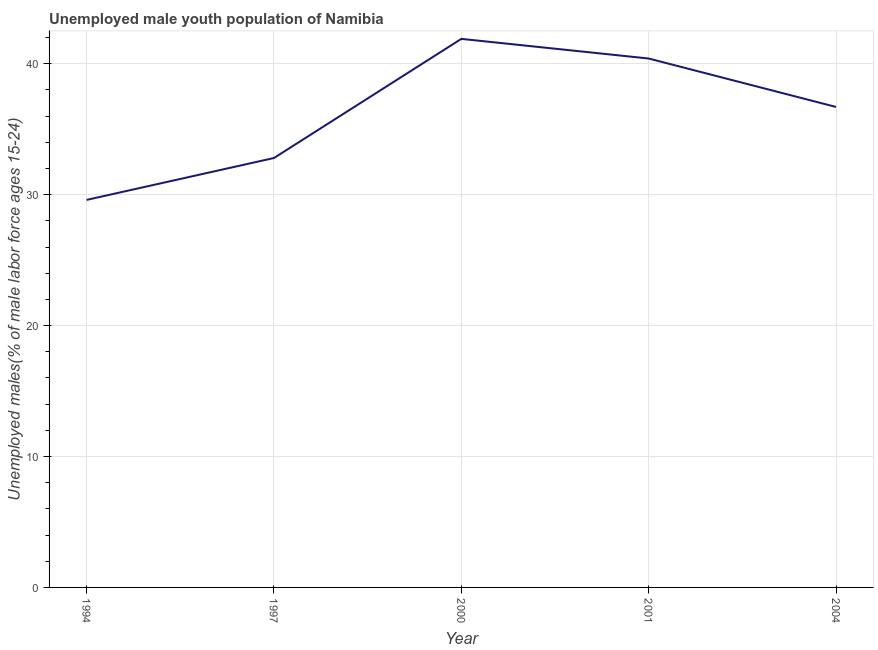What is the unemployed male youth in 2001?
Your answer should be compact. 40.4. Across all years, what is the maximum unemployed male youth?
Offer a terse response. 41.9. Across all years, what is the minimum unemployed male youth?
Your answer should be compact. 29.6. In which year was the unemployed male youth maximum?
Your answer should be compact. 2000. In which year was the unemployed male youth minimum?
Your answer should be compact. 1994. What is the sum of the unemployed male youth?
Make the answer very short. 181.4. What is the average unemployed male youth per year?
Offer a very short reply. 36.28. What is the median unemployed male youth?
Ensure brevity in your answer.  36.7. In how many years, is the unemployed male youth greater than 22 %?
Give a very brief answer. 5. Do a majority of the years between 2004 and 1997 (inclusive) have unemployed male youth greater than 24 %?
Provide a short and direct response. Yes. What is the ratio of the unemployed male youth in 2001 to that in 2004?
Provide a short and direct response. 1.1. Is the unemployed male youth in 1997 less than that in 2000?
Keep it short and to the point. Yes. What is the difference between the highest and the second highest unemployed male youth?
Offer a terse response. 1.5. Is the sum of the unemployed male youth in 2001 and 2004 greater than the maximum unemployed male youth across all years?
Offer a terse response. Yes. What is the difference between the highest and the lowest unemployed male youth?
Ensure brevity in your answer.  12.3. Does the unemployed male youth monotonically increase over the years?
Your answer should be very brief. No. What is the difference between two consecutive major ticks on the Y-axis?
Your response must be concise. 10. What is the title of the graph?
Provide a short and direct response. Unemployed male youth population of Namibia. What is the label or title of the Y-axis?
Your answer should be compact. Unemployed males(% of male labor force ages 15-24). What is the Unemployed males(% of male labor force ages 15-24) of 1994?
Provide a succinct answer. 29.6. What is the Unemployed males(% of male labor force ages 15-24) of 1997?
Make the answer very short. 32.8. What is the Unemployed males(% of male labor force ages 15-24) in 2000?
Give a very brief answer. 41.9. What is the Unemployed males(% of male labor force ages 15-24) in 2001?
Give a very brief answer. 40.4. What is the Unemployed males(% of male labor force ages 15-24) of 2004?
Keep it short and to the point. 36.7. What is the difference between the Unemployed males(% of male labor force ages 15-24) in 1994 and 1997?
Ensure brevity in your answer.  -3.2. What is the difference between the Unemployed males(% of male labor force ages 15-24) in 1994 and 2001?
Give a very brief answer. -10.8. What is the difference between the Unemployed males(% of male labor force ages 15-24) in 2001 and 2004?
Offer a very short reply. 3.7. What is the ratio of the Unemployed males(% of male labor force ages 15-24) in 1994 to that in 1997?
Make the answer very short. 0.9. What is the ratio of the Unemployed males(% of male labor force ages 15-24) in 1994 to that in 2000?
Make the answer very short. 0.71. What is the ratio of the Unemployed males(% of male labor force ages 15-24) in 1994 to that in 2001?
Offer a very short reply. 0.73. What is the ratio of the Unemployed males(% of male labor force ages 15-24) in 1994 to that in 2004?
Make the answer very short. 0.81. What is the ratio of the Unemployed males(% of male labor force ages 15-24) in 1997 to that in 2000?
Offer a very short reply. 0.78. What is the ratio of the Unemployed males(% of male labor force ages 15-24) in 1997 to that in 2001?
Provide a succinct answer. 0.81. What is the ratio of the Unemployed males(% of male labor force ages 15-24) in 1997 to that in 2004?
Keep it short and to the point. 0.89. What is the ratio of the Unemployed males(% of male labor force ages 15-24) in 2000 to that in 2001?
Provide a succinct answer. 1.04. What is the ratio of the Unemployed males(% of male labor force ages 15-24) in 2000 to that in 2004?
Your answer should be very brief. 1.14. What is the ratio of the Unemployed males(% of male labor force ages 15-24) in 2001 to that in 2004?
Provide a succinct answer. 1.1. 